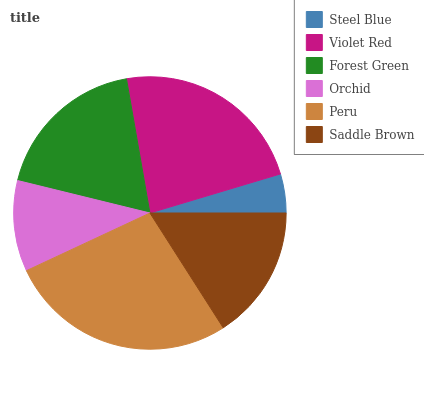Is Steel Blue the minimum?
Answer yes or no. Yes. Is Peru the maximum?
Answer yes or no. Yes. Is Violet Red the minimum?
Answer yes or no. No. Is Violet Red the maximum?
Answer yes or no. No. Is Violet Red greater than Steel Blue?
Answer yes or no. Yes. Is Steel Blue less than Violet Red?
Answer yes or no. Yes. Is Steel Blue greater than Violet Red?
Answer yes or no. No. Is Violet Red less than Steel Blue?
Answer yes or no. No. Is Forest Green the high median?
Answer yes or no. Yes. Is Saddle Brown the low median?
Answer yes or no. Yes. Is Peru the high median?
Answer yes or no. No. Is Steel Blue the low median?
Answer yes or no. No. 